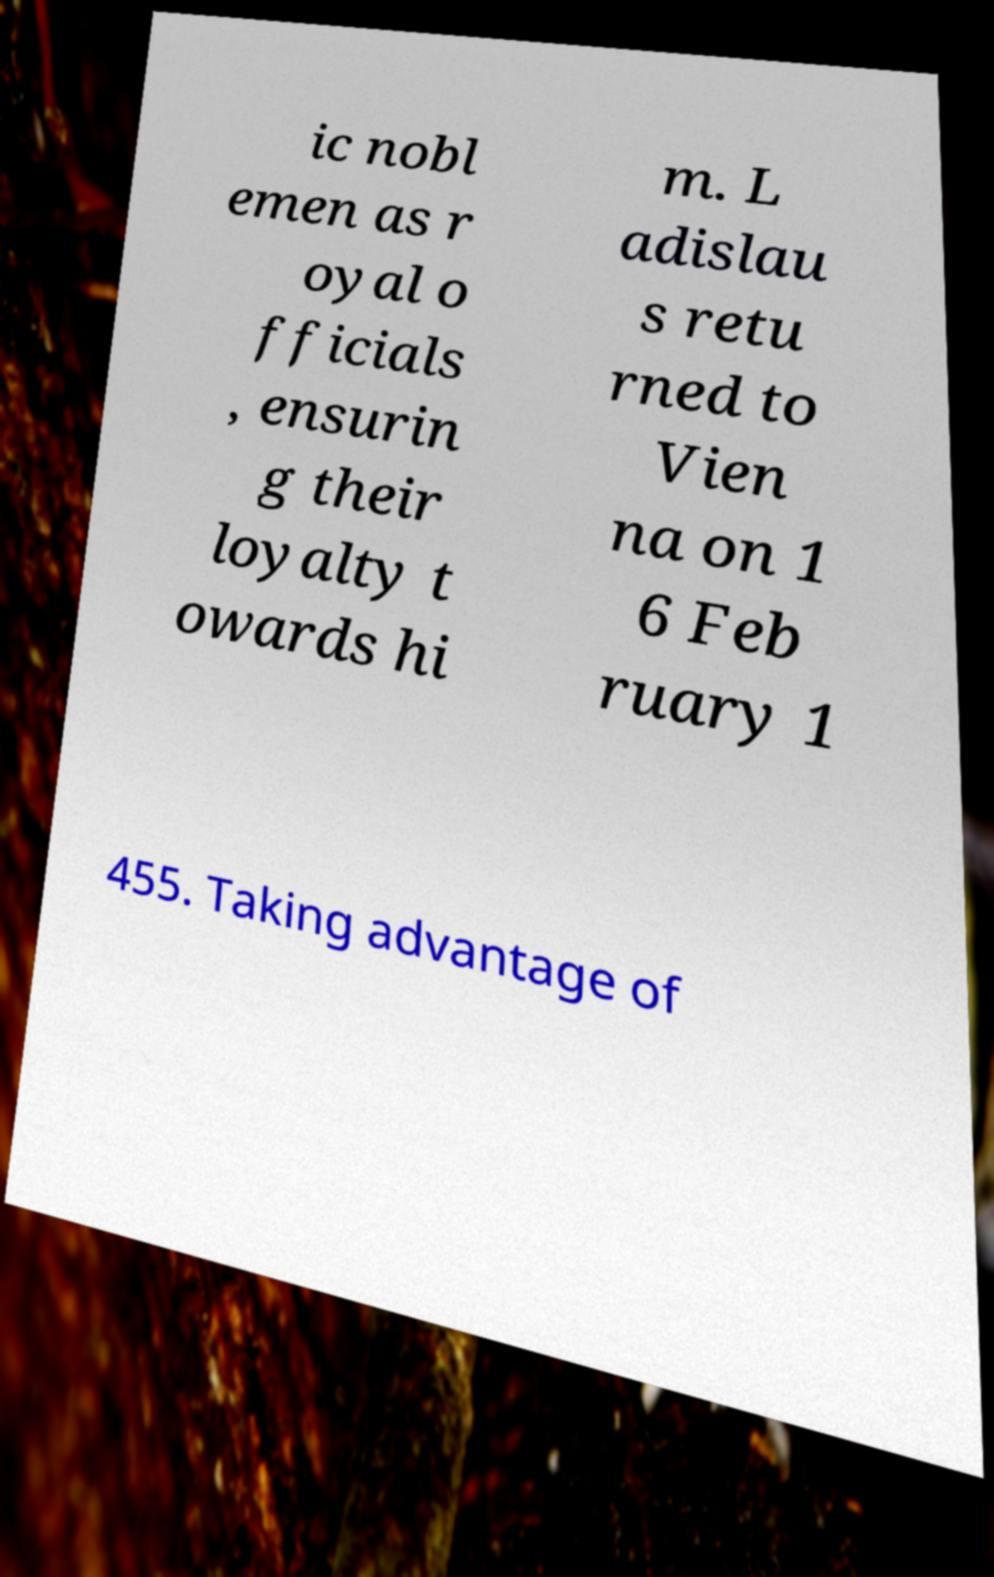I need the written content from this picture converted into text. Can you do that? ic nobl emen as r oyal o fficials , ensurin g their loyalty t owards hi m. L adislau s retu rned to Vien na on 1 6 Feb ruary 1 455. Taking advantage of 